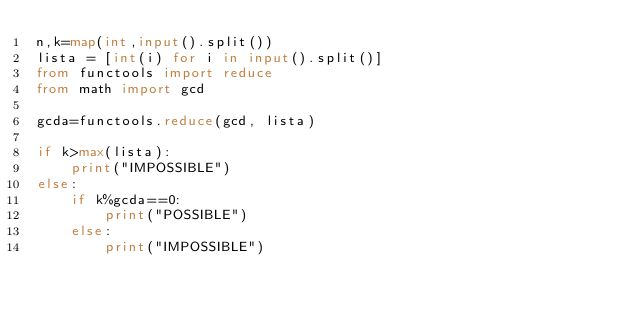<code> <loc_0><loc_0><loc_500><loc_500><_Python_>n,k=map(int,input().split())
lista = [int(i) for i in input().split()]
from functools import reduce
from math import gcd

gcda=functools.reduce(gcd, lista)

if k>max(lista):
    print("IMPOSSIBLE")
else:
    if k%gcda==0:
        print("POSSIBLE")
    else:
        print("IMPOSSIBLE")</code> 